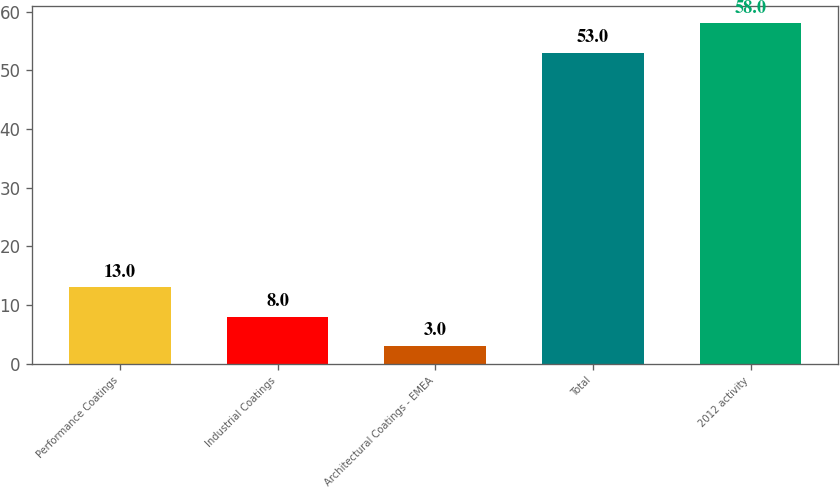Convert chart to OTSL. <chart><loc_0><loc_0><loc_500><loc_500><bar_chart><fcel>Performance Coatings<fcel>Industrial Coatings<fcel>Architectural Coatings - EMEA<fcel>Total<fcel>2012 activity<nl><fcel>13<fcel>8<fcel>3<fcel>53<fcel>58<nl></chart> 